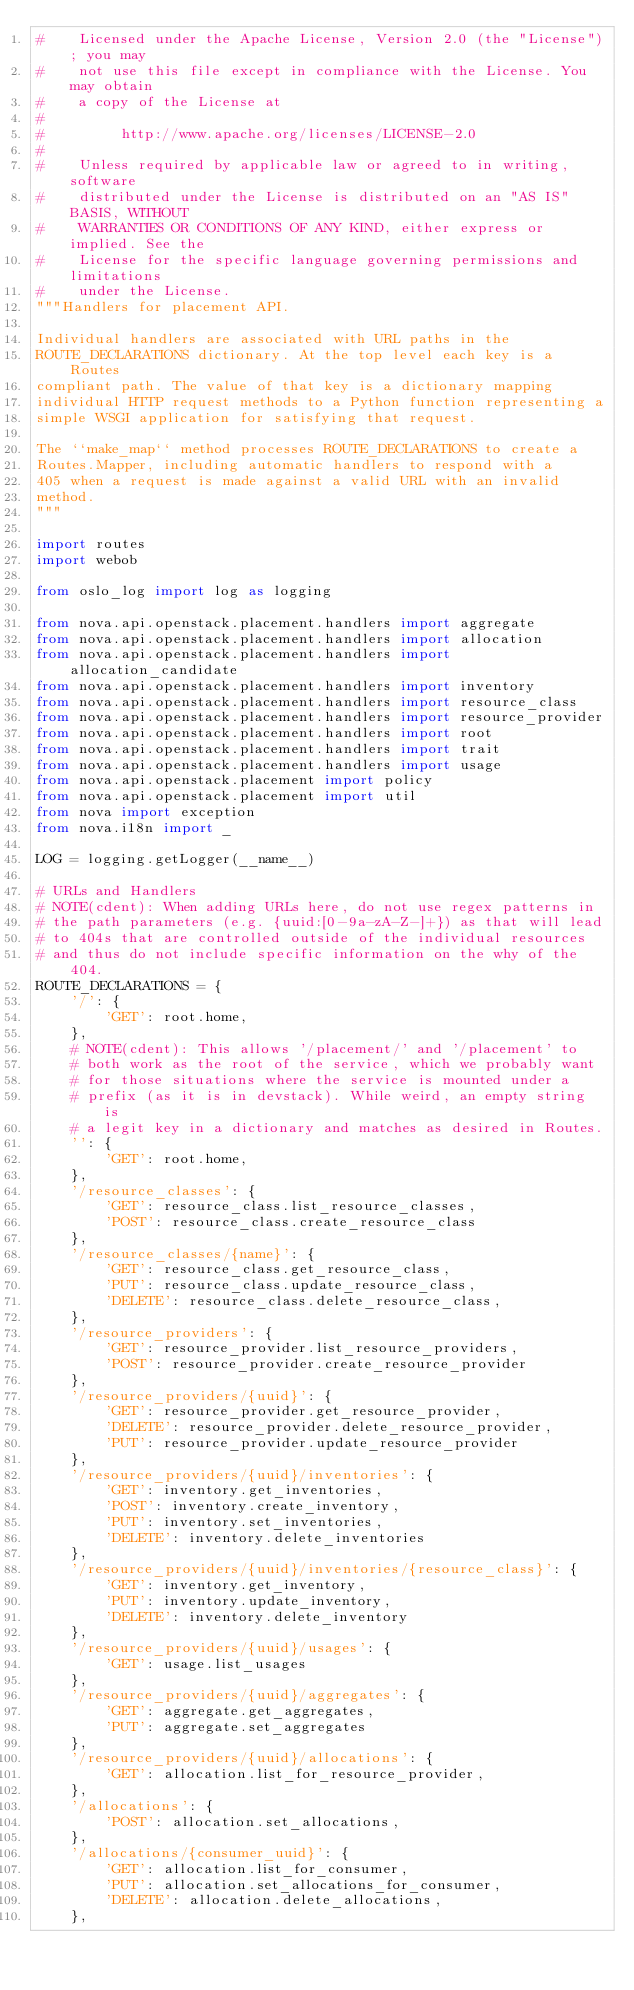Convert code to text. <code><loc_0><loc_0><loc_500><loc_500><_Python_>#    Licensed under the Apache License, Version 2.0 (the "License"); you may
#    not use this file except in compliance with the License. You may obtain
#    a copy of the License at
#
#         http://www.apache.org/licenses/LICENSE-2.0
#
#    Unless required by applicable law or agreed to in writing, software
#    distributed under the License is distributed on an "AS IS" BASIS, WITHOUT
#    WARRANTIES OR CONDITIONS OF ANY KIND, either express or implied. See the
#    License for the specific language governing permissions and limitations
#    under the License.
"""Handlers for placement API.

Individual handlers are associated with URL paths in the
ROUTE_DECLARATIONS dictionary. At the top level each key is a Routes
compliant path. The value of that key is a dictionary mapping
individual HTTP request methods to a Python function representing a
simple WSGI application for satisfying that request.

The ``make_map`` method processes ROUTE_DECLARATIONS to create a
Routes.Mapper, including automatic handlers to respond with a
405 when a request is made against a valid URL with an invalid
method.
"""

import routes
import webob

from oslo_log import log as logging

from nova.api.openstack.placement.handlers import aggregate
from nova.api.openstack.placement.handlers import allocation
from nova.api.openstack.placement.handlers import allocation_candidate
from nova.api.openstack.placement.handlers import inventory
from nova.api.openstack.placement.handlers import resource_class
from nova.api.openstack.placement.handlers import resource_provider
from nova.api.openstack.placement.handlers import root
from nova.api.openstack.placement.handlers import trait
from nova.api.openstack.placement.handlers import usage
from nova.api.openstack.placement import policy
from nova.api.openstack.placement import util
from nova import exception
from nova.i18n import _

LOG = logging.getLogger(__name__)

# URLs and Handlers
# NOTE(cdent): When adding URLs here, do not use regex patterns in
# the path parameters (e.g. {uuid:[0-9a-zA-Z-]+}) as that will lead
# to 404s that are controlled outside of the individual resources
# and thus do not include specific information on the why of the 404.
ROUTE_DECLARATIONS = {
    '/': {
        'GET': root.home,
    },
    # NOTE(cdent): This allows '/placement/' and '/placement' to
    # both work as the root of the service, which we probably want
    # for those situations where the service is mounted under a
    # prefix (as it is in devstack). While weird, an empty string is
    # a legit key in a dictionary and matches as desired in Routes.
    '': {
        'GET': root.home,
    },
    '/resource_classes': {
        'GET': resource_class.list_resource_classes,
        'POST': resource_class.create_resource_class
    },
    '/resource_classes/{name}': {
        'GET': resource_class.get_resource_class,
        'PUT': resource_class.update_resource_class,
        'DELETE': resource_class.delete_resource_class,
    },
    '/resource_providers': {
        'GET': resource_provider.list_resource_providers,
        'POST': resource_provider.create_resource_provider
    },
    '/resource_providers/{uuid}': {
        'GET': resource_provider.get_resource_provider,
        'DELETE': resource_provider.delete_resource_provider,
        'PUT': resource_provider.update_resource_provider
    },
    '/resource_providers/{uuid}/inventories': {
        'GET': inventory.get_inventories,
        'POST': inventory.create_inventory,
        'PUT': inventory.set_inventories,
        'DELETE': inventory.delete_inventories
    },
    '/resource_providers/{uuid}/inventories/{resource_class}': {
        'GET': inventory.get_inventory,
        'PUT': inventory.update_inventory,
        'DELETE': inventory.delete_inventory
    },
    '/resource_providers/{uuid}/usages': {
        'GET': usage.list_usages
    },
    '/resource_providers/{uuid}/aggregates': {
        'GET': aggregate.get_aggregates,
        'PUT': aggregate.set_aggregates
    },
    '/resource_providers/{uuid}/allocations': {
        'GET': allocation.list_for_resource_provider,
    },
    '/allocations': {
        'POST': allocation.set_allocations,
    },
    '/allocations/{consumer_uuid}': {
        'GET': allocation.list_for_consumer,
        'PUT': allocation.set_allocations_for_consumer,
        'DELETE': allocation.delete_allocations,
    },</code> 